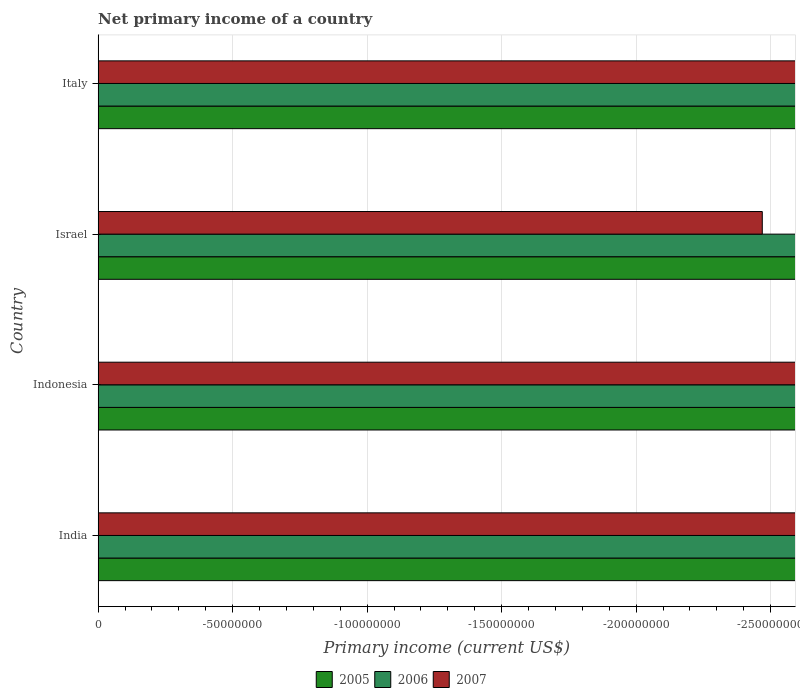How many different coloured bars are there?
Ensure brevity in your answer.  0. Are the number of bars on each tick of the Y-axis equal?
Make the answer very short. Yes. How many bars are there on the 1st tick from the top?
Ensure brevity in your answer.  0. How many bars are there on the 4th tick from the bottom?
Your answer should be very brief. 0. What is the label of the 2nd group of bars from the top?
Your answer should be compact. Israel. Across all countries, what is the minimum primary income in 2007?
Offer a very short reply. 0. What is the total primary income in 2006 in the graph?
Your response must be concise. 0. What is the difference between the primary income in 2007 in Israel and the primary income in 2006 in Italy?
Your answer should be very brief. 0. How many bars are there?
Offer a very short reply. 0. Are all the bars in the graph horizontal?
Make the answer very short. Yes. How many countries are there in the graph?
Give a very brief answer. 4. Does the graph contain grids?
Give a very brief answer. Yes. How are the legend labels stacked?
Provide a succinct answer. Horizontal. What is the title of the graph?
Keep it short and to the point. Net primary income of a country. What is the label or title of the X-axis?
Your response must be concise. Primary income (current US$). What is the Primary income (current US$) of 2005 in Indonesia?
Keep it short and to the point. 0. What is the Primary income (current US$) of 2006 in Indonesia?
Give a very brief answer. 0. What is the Primary income (current US$) in 2007 in Indonesia?
Your response must be concise. 0. What is the Primary income (current US$) in 2006 in Israel?
Keep it short and to the point. 0. What is the Primary income (current US$) of 2007 in Israel?
Offer a very short reply. 0. What is the Primary income (current US$) of 2005 in Italy?
Ensure brevity in your answer.  0. What is the Primary income (current US$) of 2007 in Italy?
Your response must be concise. 0. What is the total Primary income (current US$) of 2006 in the graph?
Give a very brief answer. 0. What is the average Primary income (current US$) in 2005 per country?
Your answer should be very brief. 0. What is the average Primary income (current US$) in 2007 per country?
Your answer should be very brief. 0. 